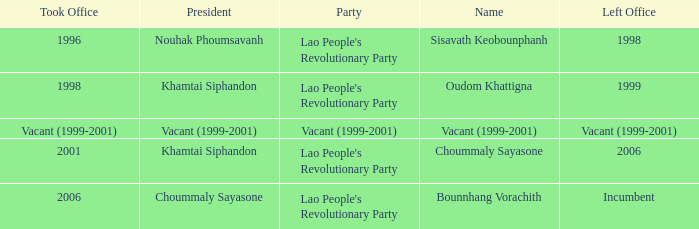What is Left Office, when Party is Vacant (1999-2001)? Vacant (1999-2001). 